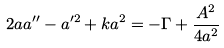<formula> <loc_0><loc_0><loc_500><loc_500>2 a a ^ { \prime \prime } - a ^ { \prime 2 } + k a ^ { 2 } = - \Gamma + \frac { A ^ { 2 } } { 4 a ^ { 2 } }</formula> 